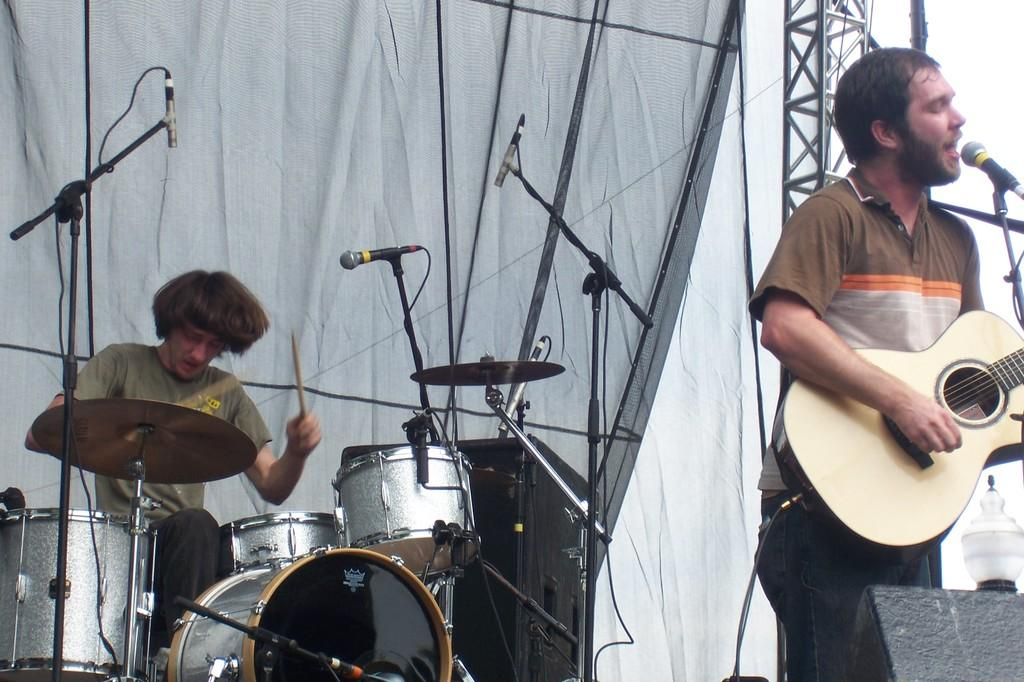What is the man in the image doing? The man is singing with a microphone and playing a guitar. Are there any other people in the image? Yes, there is another man in the image. What is the second man doing? The second man is playing drums. What type of apparatus is the man using to communicate with his brother in the image? There is no mention of a brother or any communication apparatus in the image. Can you see a bridge in the background of the image? There is no bridge visible in the image. 